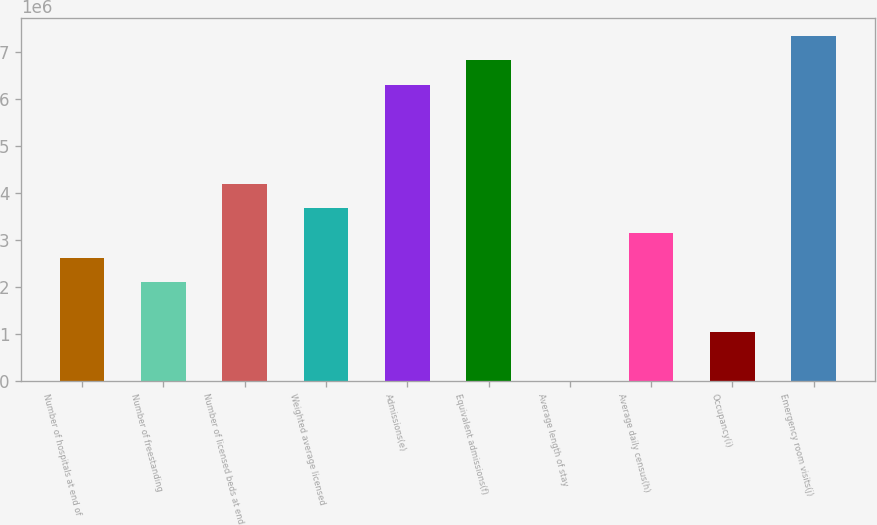Convert chart to OTSL. <chart><loc_0><loc_0><loc_500><loc_500><bar_chart><fcel>Number of hospitals at end of<fcel>Number of freestanding<fcel>Number of licensed beds at end<fcel>Weighted average licensed<fcel>Admissions(e)<fcel>Equivalent admissions(f)<fcel>Average length of stay<fcel>Average daily census(h)<fcel>Occupancy(i)<fcel>Emergency room visits(j)<nl><fcel>2.6232e+06<fcel>2.09856e+06<fcel>4.19712e+06<fcel>3.67248e+06<fcel>6.29568e+06<fcel>6.82032e+06<fcel>4.9<fcel>3.14784e+06<fcel>1.04928e+06<fcel>7.34496e+06<nl></chart> 